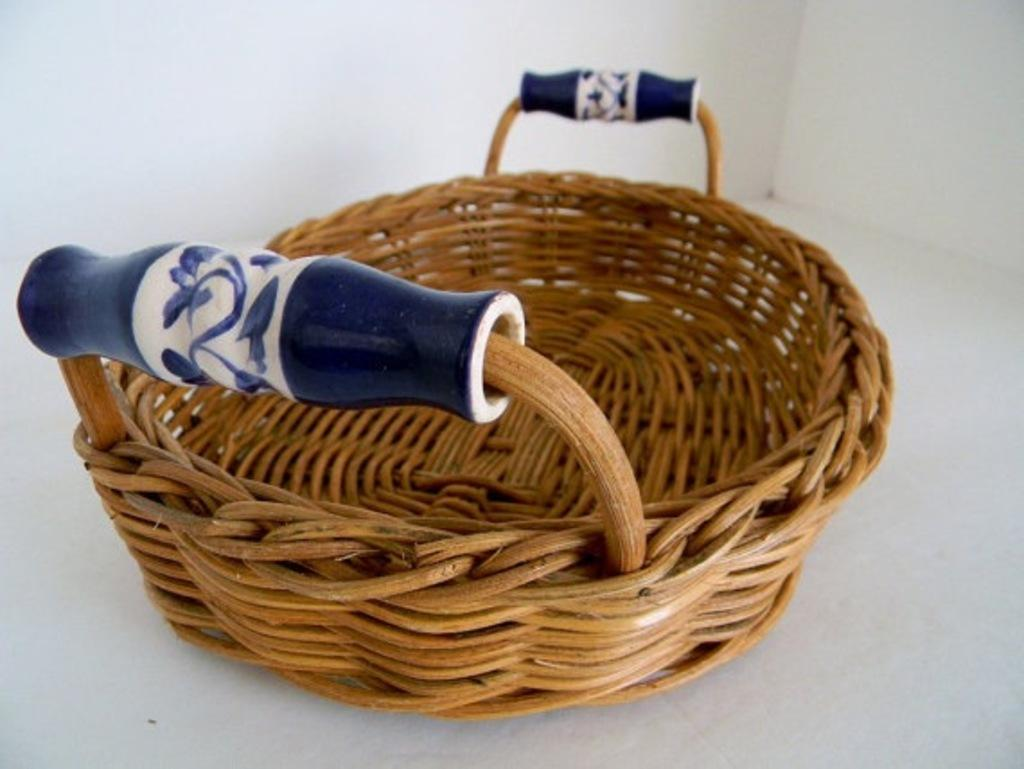What object can be seen in the image that is made of wood? There is a wooden basket in the image. Can you describe the possible presence of a structure in the image? There may be a wall at the top of the image. How many holes are visible in the wooden basket in the image? There is no mention of any holes in the wooden basket in the provided facts, so we cannot determine the number of holes from the image. 